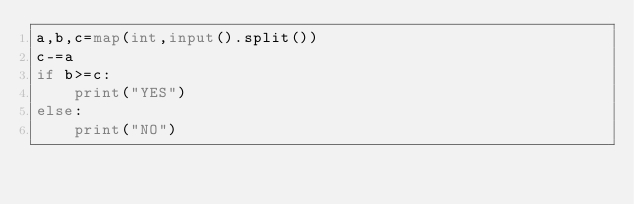<code> <loc_0><loc_0><loc_500><loc_500><_Python_>a,b,c=map(int,input().split())
c-=a
if b>=c:
    print("YES")
else:
    print("NO")</code> 